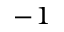<formula> <loc_0><loc_0><loc_500><loc_500>^ { - 1 }</formula> 